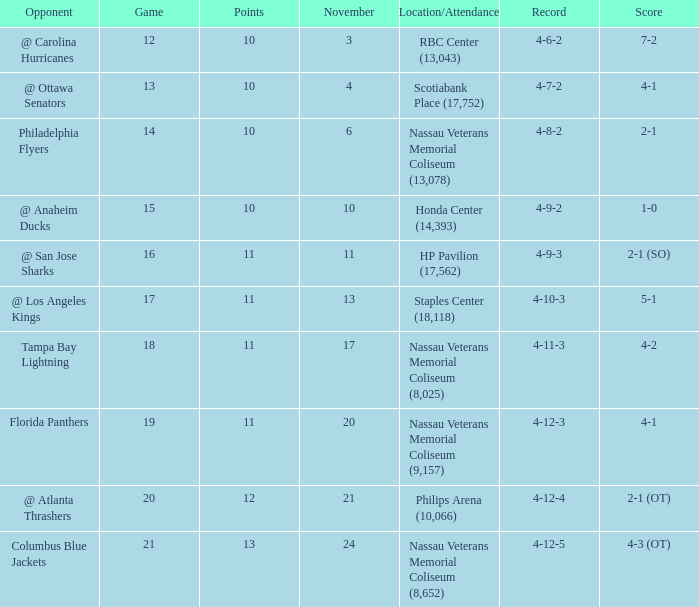What is every game on November 21? 20.0. 